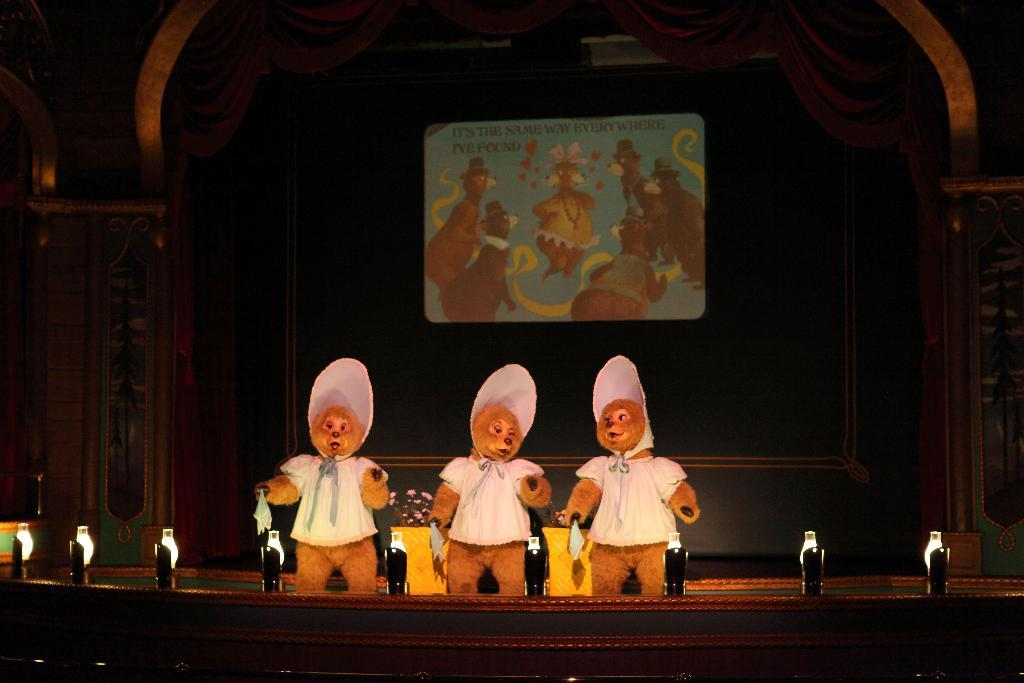How many people are in the image? There are three persons in the image. What are the persons wearing? The persons are wearing different costumes. Where are the persons standing in the image? The persons are standing on a stage. What can be seen in the background of the image? There is a screen attached to a wall. How many bikes are visible in the image? There are no bikes present in the image. What trick is the person performing on the stage? The image does not show any tricks being performed; it only shows the persons standing on the stage wearing different costumes. 